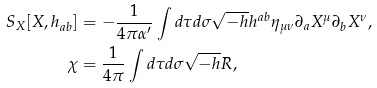<formula> <loc_0><loc_0><loc_500><loc_500>S _ { X } [ X , h _ { a b } ] & = - \frac { 1 } { 4 \pi \alpha ^ { \prime } } \int d \tau d \sigma \sqrt { - h } h ^ { a b } \eta _ { \mu \nu } \partial _ { a } X ^ { \mu } \partial _ { b } X ^ { \nu } , \\ \chi & = \frac { 1 } { 4 \pi } \int d \tau d \sigma \sqrt { - h } R ,</formula> 